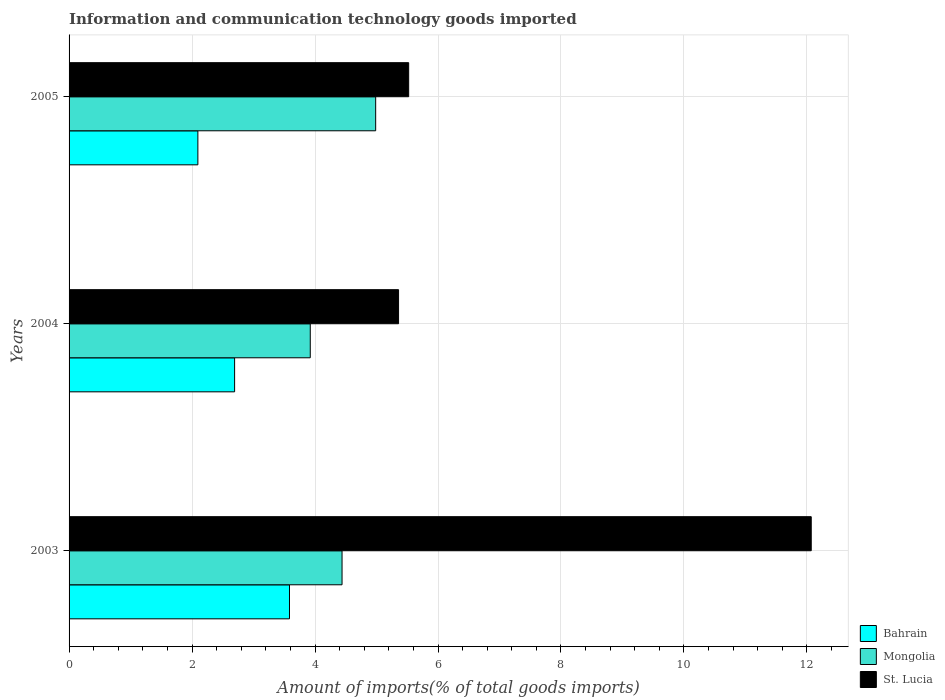Are the number of bars on each tick of the Y-axis equal?
Your response must be concise. Yes. How many bars are there on the 1st tick from the top?
Give a very brief answer. 3. What is the amount of goods imported in Mongolia in 2003?
Your answer should be very brief. 4.44. Across all years, what is the maximum amount of goods imported in St. Lucia?
Keep it short and to the point. 12.07. Across all years, what is the minimum amount of goods imported in St. Lucia?
Provide a short and direct response. 5.36. In which year was the amount of goods imported in Bahrain minimum?
Provide a succinct answer. 2005. What is the total amount of goods imported in Bahrain in the graph?
Keep it short and to the point. 8.37. What is the difference between the amount of goods imported in Bahrain in 2004 and that in 2005?
Your answer should be compact. 0.6. What is the difference between the amount of goods imported in St. Lucia in 2004 and the amount of goods imported in Bahrain in 2005?
Your response must be concise. 3.26. What is the average amount of goods imported in Bahrain per year?
Make the answer very short. 2.79. In the year 2005, what is the difference between the amount of goods imported in St. Lucia and amount of goods imported in Mongolia?
Your answer should be very brief. 0.54. What is the ratio of the amount of goods imported in St. Lucia in 2003 to that in 2005?
Keep it short and to the point. 2.19. Is the amount of goods imported in St. Lucia in 2003 less than that in 2005?
Keep it short and to the point. No. Is the difference between the amount of goods imported in St. Lucia in 2003 and 2004 greater than the difference between the amount of goods imported in Mongolia in 2003 and 2004?
Keep it short and to the point. Yes. What is the difference between the highest and the second highest amount of goods imported in St. Lucia?
Your response must be concise. 6.55. What is the difference between the highest and the lowest amount of goods imported in Mongolia?
Offer a very short reply. 1.06. What does the 1st bar from the top in 2003 represents?
Keep it short and to the point. St. Lucia. What does the 3rd bar from the bottom in 2003 represents?
Ensure brevity in your answer.  St. Lucia. Is it the case that in every year, the sum of the amount of goods imported in St. Lucia and amount of goods imported in Mongolia is greater than the amount of goods imported in Bahrain?
Your response must be concise. Yes. How many years are there in the graph?
Keep it short and to the point. 3. What is the difference between two consecutive major ticks on the X-axis?
Provide a short and direct response. 2. Are the values on the major ticks of X-axis written in scientific E-notation?
Your response must be concise. No. Does the graph contain any zero values?
Offer a very short reply. No. How are the legend labels stacked?
Provide a short and direct response. Vertical. What is the title of the graph?
Provide a succinct answer. Information and communication technology goods imported. Does "Turkmenistan" appear as one of the legend labels in the graph?
Your response must be concise. No. What is the label or title of the X-axis?
Offer a terse response. Amount of imports(% of total goods imports). What is the label or title of the Y-axis?
Your answer should be very brief. Years. What is the Amount of imports(% of total goods imports) in Bahrain in 2003?
Offer a very short reply. 3.58. What is the Amount of imports(% of total goods imports) of Mongolia in 2003?
Provide a succinct answer. 4.44. What is the Amount of imports(% of total goods imports) of St. Lucia in 2003?
Keep it short and to the point. 12.07. What is the Amount of imports(% of total goods imports) of Bahrain in 2004?
Provide a short and direct response. 2.69. What is the Amount of imports(% of total goods imports) of Mongolia in 2004?
Your answer should be compact. 3.92. What is the Amount of imports(% of total goods imports) of St. Lucia in 2004?
Keep it short and to the point. 5.36. What is the Amount of imports(% of total goods imports) in Bahrain in 2005?
Make the answer very short. 2.09. What is the Amount of imports(% of total goods imports) in Mongolia in 2005?
Your answer should be very brief. 4.99. What is the Amount of imports(% of total goods imports) of St. Lucia in 2005?
Provide a succinct answer. 5.52. Across all years, what is the maximum Amount of imports(% of total goods imports) in Bahrain?
Offer a very short reply. 3.58. Across all years, what is the maximum Amount of imports(% of total goods imports) of Mongolia?
Provide a short and direct response. 4.99. Across all years, what is the maximum Amount of imports(% of total goods imports) in St. Lucia?
Offer a very short reply. 12.07. Across all years, what is the minimum Amount of imports(% of total goods imports) of Bahrain?
Your response must be concise. 2.09. Across all years, what is the minimum Amount of imports(% of total goods imports) of Mongolia?
Your answer should be compact. 3.92. Across all years, what is the minimum Amount of imports(% of total goods imports) in St. Lucia?
Give a very brief answer. 5.36. What is the total Amount of imports(% of total goods imports) in Bahrain in the graph?
Provide a succinct answer. 8.37. What is the total Amount of imports(% of total goods imports) in Mongolia in the graph?
Give a very brief answer. 13.35. What is the total Amount of imports(% of total goods imports) in St. Lucia in the graph?
Ensure brevity in your answer.  22.95. What is the difference between the Amount of imports(% of total goods imports) in Bahrain in 2003 and that in 2004?
Keep it short and to the point. 0.89. What is the difference between the Amount of imports(% of total goods imports) of Mongolia in 2003 and that in 2004?
Offer a very short reply. 0.52. What is the difference between the Amount of imports(% of total goods imports) of St. Lucia in 2003 and that in 2004?
Provide a short and direct response. 6.71. What is the difference between the Amount of imports(% of total goods imports) of Bahrain in 2003 and that in 2005?
Your response must be concise. 1.49. What is the difference between the Amount of imports(% of total goods imports) in Mongolia in 2003 and that in 2005?
Your answer should be very brief. -0.55. What is the difference between the Amount of imports(% of total goods imports) in St. Lucia in 2003 and that in 2005?
Offer a terse response. 6.55. What is the difference between the Amount of imports(% of total goods imports) in Bahrain in 2004 and that in 2005?
Your answer should be very brief. 0.6. What is the difference between the Amount of imports(% of total goods imports) in Mongolia in 2004 and that in 2005?
Provide a succinct answer. -1.06. What is the difference between the Amount of imports(% of total goods imports) in St. Lucia in 2004 and that in 2005?
Keep it short and to the point. -0.16. What is the difference between the Amount of imports(% of total goods imports) of Bahrain in 2003 and the Amount of imports(% of total goods imports) of Mongolia in 2004?
Make the answer very short. -0.34. What is the difference between the Amount of imports(% of total goods imports) in Bahrain in 2003 and the Amount of imports(% of total goods imports) in St. Lucia in 2004?
Your response must be concise. -1.77. What is the difference between the Amount of imports(% of total goods imports) of Mongolia in 2003 and the Amount of imports(% of total goods imports) of St. Lucia in 2004?
Your answer should be very brief. -0.92. What is the difference between the Amount of imports(% of total goods imports) of Bahrain in 2003 and the Amount of imports(% of total goods imports) of Mongolia in 2005?
Offer a terse response. -1.4. What is the difference between the Amount of imports(% of total goods imports) in Bahrain in 2003 and the Amount of imports(% of total goods imports) in St. Lucia in 2005?
Your answer should be very brief. -1.94. What is the difference between the Amount of imports(% of total goods imports) of Mongolia in 2003 and the Amount of imports(% of total goods imports) of St. Lucia in 2005?
Offer a terse response. -1.08. What is the difference between the Amount of imports(% of total goods imports) in Bahrain in 2004 and the Amount of imports(% of total goods imports) in Mongolia in 2005?
Your response must be concise. -2.29. What is the difference between the Amount of imports(% of total goods imports) in Bahrain in 2004 and the Amount of imports(% of total goods imports) in St. Lucia in 2005?
Offer a terse response. -2.83. What is the difference between the Amount of imports(% of total goods imports) of Mongolia in 2004 and the Amount of imports(% of total goods imports) of St. Lucia in 2005?
Offer a terse response. -1.6. What is the average Amount of imports(% of total goods imports) in Bahrain per year?
Offer a terse response. 2.79. What is the average Amount of imports(% of total goods imports) of Mongolia per year?
Offer a terse response. 4.45. What is the average Amount of imports(% of total goods imports) of St. Lucia per year?
Provide a succinct answer. 7.65. In the year 2003, what is the difference between the Amount of imports(% of total goods imports) in Bahrain and Amount of imports(% of total goods imports) in Mongolia?
Offer a very short reply. -0.85. In the year 2003, what is the difference between the Amount of imports(% of total goods imports) of Bahrain and Amount of imports(% of total goods imports) of St. Lucia?
Offer a terse response. -8.49. In the year 2003, what is the difference between the Amount of imports(% of total goods imports) in Mongolia and Amount of imports(% of total goods imports) in St. Lucia?
Provide a succinct answer. -7.63. In the year 2004, what is the difference between the Amount of imports(% of total goods imports) in Bahrain and Amount of imports(% of total goods imports) in Mongolia?
Provide a short and direct response. -1.23. In the year 2004, what is the difference between the Amount of imports(% of total goods imports) of Bahrain and Amount of imports(% of total goods imports) of St. Lucia?
Your response must be concise. -2.67. In the year 2004, what is the difference between the Amount of imports(% of total goods imports) in Mongolia and Amount of imports(% of total goods imports) in St. Lucia?
Ensure brevity in your answer.  -1.44. In the year 2005, what is the difference between the Amount of imports(% of total goods imports) of Bahrain and Amount of imports(% of total goods imports) of Mongolia?
Give a very brief answer. -2.89. In the year 2005, what is the difference between the Amount of imports(% of total goods imports) of Bahrain and Amount of imports(% of total goods imports) of St. Lucia?
Offer a terse response. -3.43. In the year 2005, what is the difference between the Amount of imports(% of total goods imports) in Mongolia and Amount of imports(% of total goods imports) in St. Lucia?
Ensure brevity in your answer.  -0.54. What is the ratio of the Amount of imports(% of total goods imports) in Bahrain in 2003 to that in 2004?
Give a very brief answer. 1.33. What is the ratio of the Amount of imports(% of total goods imports) of Mongolia in 2003 to that in 2004?
Your answer should be compact. 1.13. What is the ratio of the Amount of imports(% of total goods imports) of St. Lucia in 2003 to that in 2004?
Provide a short and direct response. 2.25. What is the ratio of the Amount of imports(% of total goods imports) in Bahrain in 2003 to that in 2005?
Your answer should be very brief. 1.71. What is the ratio of the Amount of imports(% of total goods imports) in Mongolia in 2003 to that in 2005?
Your response must be concise. 0.89. What is the ratio of the Amount of imports(% of total goods imports) of St. Lucia in 2003 to that in 2005?
Give a very brief answer. 2.19. What is the ratio of the Amount of imports(% of total goods imports) of Bahrain in 2004 to that in 2005?
Offer a very short reply. 1.29. What is the ratio of the Amount of imports(% of total goods imports) of Mongolia in 2004 to that in 2005?
Give a very brief answer. 0.79. What is the ratio of the Amount of imports(% of total goods imports) in St. Lucia in 2004 to that in 2005?
Make the answer very short. 0.97. What is the difference between the highest and the second highest Amount of imports(% of total goods imports) of Bahrain?
Provide a succinct answer. 0.89. What is the difference between the highest and the second highest Amount of imports(% of total goods imports) of Mongolia?
Your answer should be compact. 0.55. What is the difference between the highest and the second highest Amount of imports(% of total goods imports) of St. Lucia?
Keep it short and to the point. 6.55. What is the difference between the highest and the lowest Amount of imports(% of total goods imports) in Bahrain?
Provide a short and direct response. 1.49. What is the difference between the highest and the lowest Amount of imports(% of total goods imports) of Mongolia?
Offer a terse response. 1.06. What is the difference between the highest and the lowest Amount of imports(% of total goods imports) of St. Lucia?
Offer a very short reply. 6.71. 